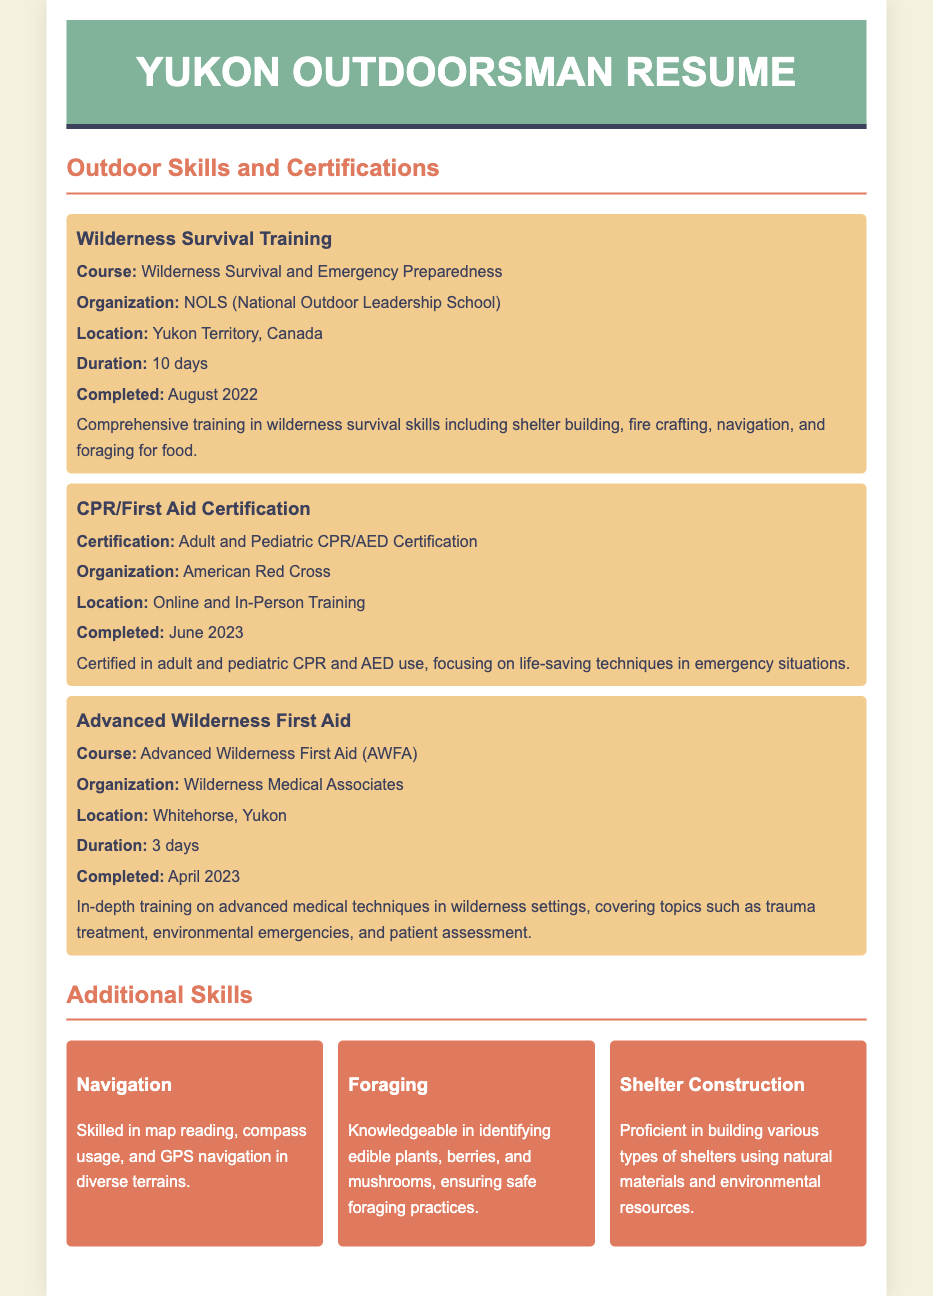What course did you complete for Wilderness Survival Training? The course completed for Wilderness Survival Training is titled "Wilderness Survival and Emergency Preparedness."
Answer: Wilderness Survival and Emergency Preparedness Which organization provided the CPR/First Aid Certification? The organization that provided the CPR/First Aid Certification is the American Red Cross.
Answer: American Red Cross When was the Advanced Wilderness First Aid course completed? The Advanced Wilderness First Aid course was completed in April 2023.
Answer: April 2023 How long did the Wilderness Survival Training last? The Wilderness Survival Training lasted for 10 days.
Answer: 10 days What advanced medical topics are covered in the Advanced Wilderness First Aid course? The Advanced Wilderness First Aid course covers topics such as trauma treatment, environmental emergencies, and patient assessment.
Answer: Trauma treatment, environmental emergencies, patient assessment How does the CPR/First Aid Certification prepare you for emergencies? The certification focuses on life-saving techniques in emergency situations.
Answer: Life-saving techniques What were the locations for the Wilderness Survival Training and Advanced Wilderness First Aid? The Wilderness Survival Training was in Yukon Territory, Canada, and the Advanced Wilderness First Aid was in Whitehorse, Yukon.
Answer: Yukon Territory, Canada; Whitehorse, Yukon Which skills are listed as additional skills in the resume? The additional skills listed include navigation, foraging, and shelter construction.
Answer: Navigation, foraging, shelter construction 